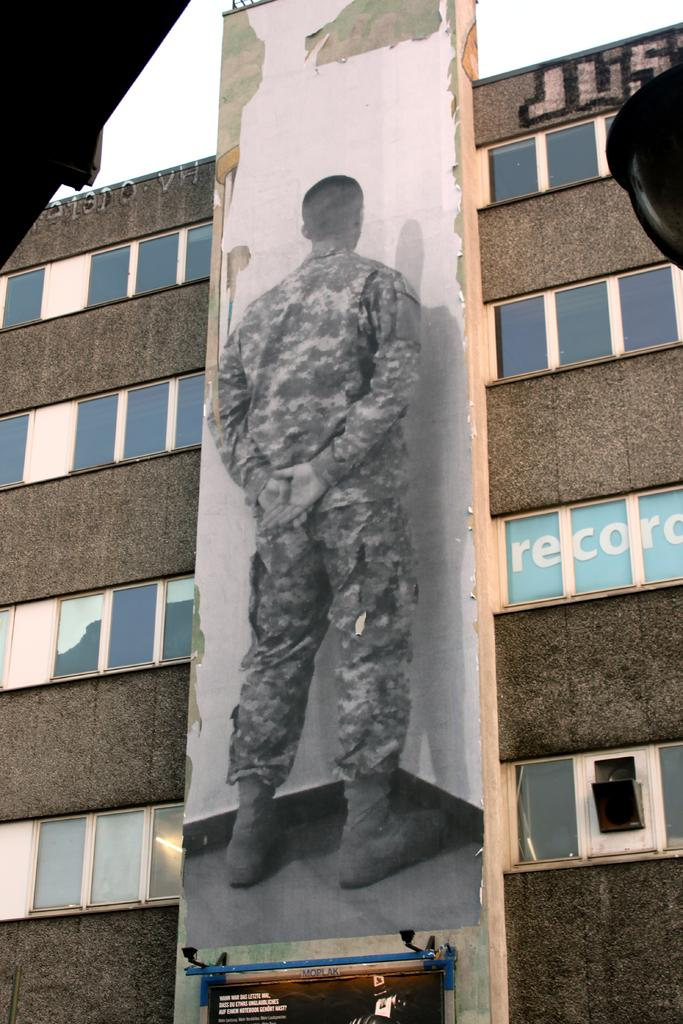What is the main subject in the center of the image? There is a hoarding in the center of the image. What other structure can be seen in the image? There is a building in the image. What type of windows does the building have? The building has glass windows. How many feet are visible in the image? There are no feet visible in the image. What type of field can be seen in the background of the image? There is no field present in the image. 